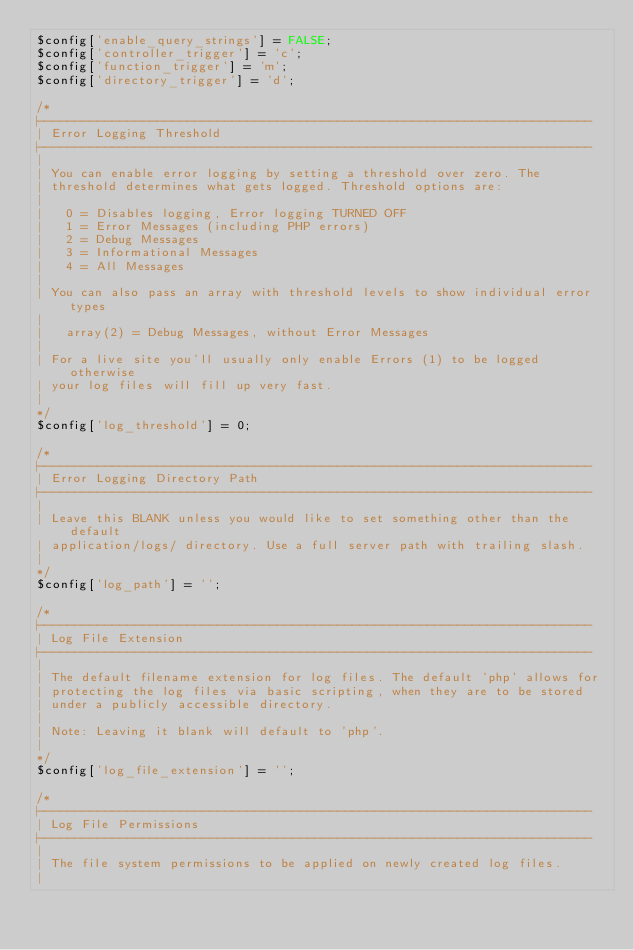<code> <loc_0><loc_0><loc_500><loc_500><_PHP_>$config['enable_query_strings'] = FALSE;
$config['controller_trigger'] = 'c';
$config['function_trigger'] = 'm';
$config['directory_trigger'] = 'd';

/*
|--------------------------------------------------------------------------
| Error Logging Threshold
|--------------------------------------------------------------------------
|
| You can enable error logging by setting a threshold over zero. The
| threshold determines what gets logged. Threshold options are:
|
|	0 = Disables logging, Error logging TURNED OFF
|	1 = Error Messages (including PHP errors)
|	2 = Debug Messages
|	3 = Informational Messages
|	4 = All Messages
|
| You can also pass an array with threshold levels to show individual error types
|
| 	array(2) = Debug Messages, without Error Messages
|
| For a live site you'll usually only enable Errors (1) to be logged otherwise
| your log files will fill up very fast.
|
*/
$config['log_threshold'] = 0;

/*
|--------------------------------------------------------------------------
| Error Logging Directory Path
|--------------------------------------------------------------------------
|
| Leave this BLANK unless you would like to set something other than the default
| application/logs/ directory. Use a full server path with trailing slash.
|
*/
$config['log_path'] = '';

/*
|--------------------------------------------------------------------------
| Log File Extension
|--------------------------------------------------------------------------
|
| The default filename extension for log files. The default 'php' allows for
| protecting the log files via basic scripting, when they are to be stored
| under a publicly accessible directory.
|
| Note: Leaving it blank will default to 'php'.
|
*/
$config['log_file_extension'] = '';

/*
|--------------------------------------------------------------------------
| Log File Permissions
|--------------------------------------------------------------------------
|
| The file system permissions to be applied on newly created log files.
|</code> 